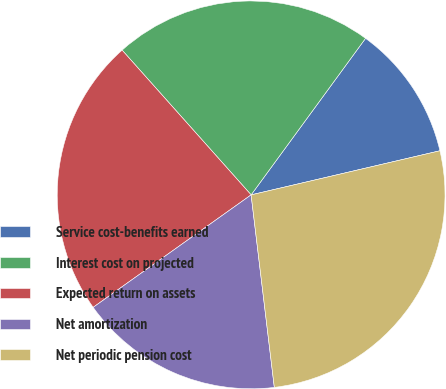Convert chart to OTSL. <chart><loc_0><loc_0><loc_500><loc_500><pie_chart><fcel>Service cost-benefits earned<fcel>Interest cost on projected<fcel>Expected return on assets<fcel>Net amortization<fcel>Net periodic pension cost<nl><fcel>11.3%<fcel>21.63%<fcel>23.26%<fcel>17.06%<fcel>26.74%<nl></chart> 